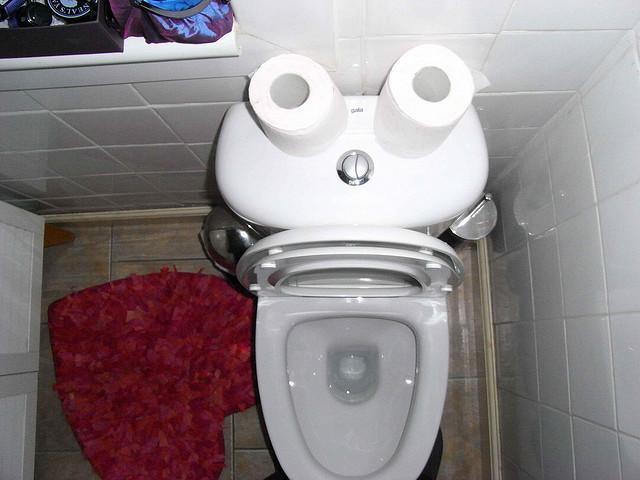How many toilet tissues are there?
Give a very brief answer. 2. 